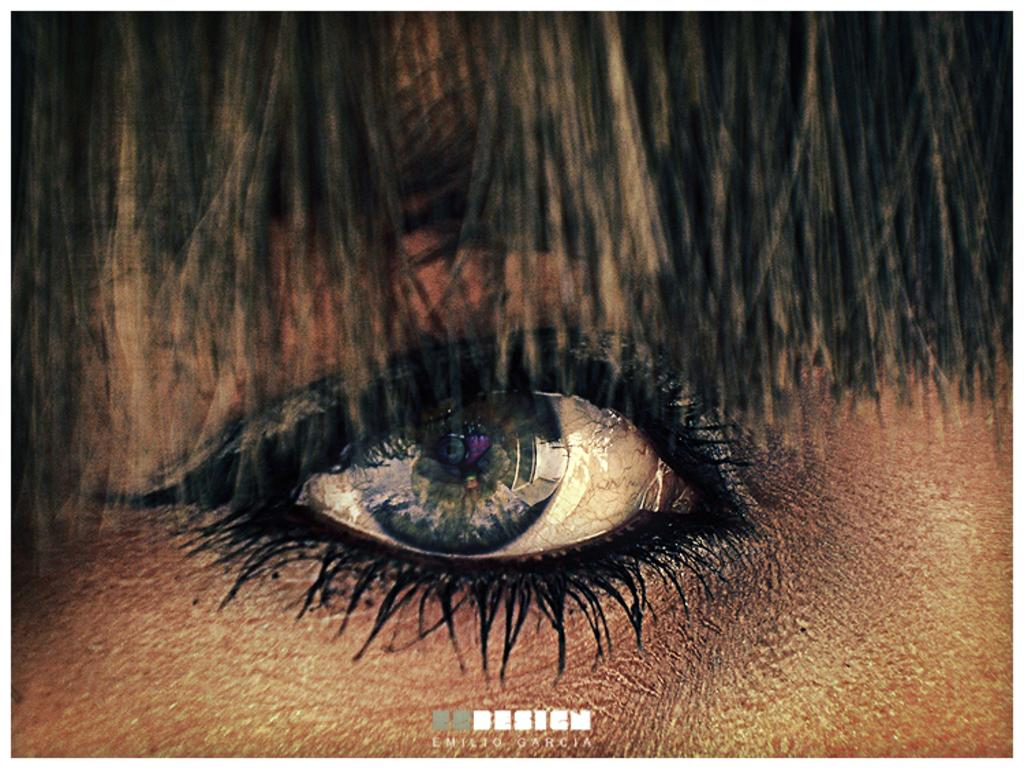What is the main subject of the picture? The main subject of the picture is an eye. Whose eye is it? The eye belongs to a person. What can be seen above the eye in the picture? There are black hairs visible above the eye in the picture. How many dolls are sitting on the person's head in the picture? There are no dolls present in the image; it only features a person's eye with black hairs above it. What type of horn is attached to the person's forehead in the picture? There is no horn present in the image; it only features a person's eye with black hairs above it. 